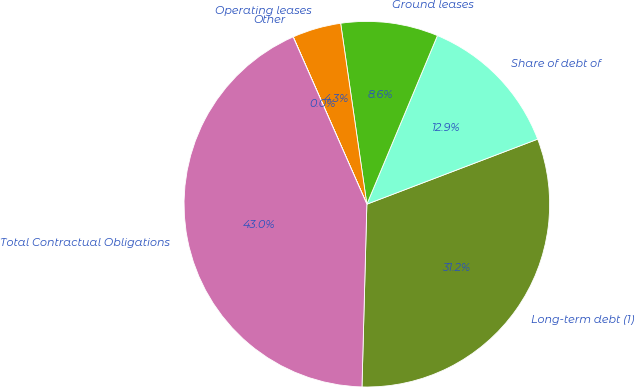<chart> <loc_0><loc_0><loc_500><loc_500><pie_chart><fcel>Long-term debt (1)<fcel>Share of debt of<fcel>Ground leases<fcel>Operating leases<fcel>Other<fcel>Total Contractual Obligations<nl><fcel>31.22%<fcel>12.9%<fcel>8.6%<fcel>4.31%<fcel>0.01%<fcel>42.97%<nl></chart> 